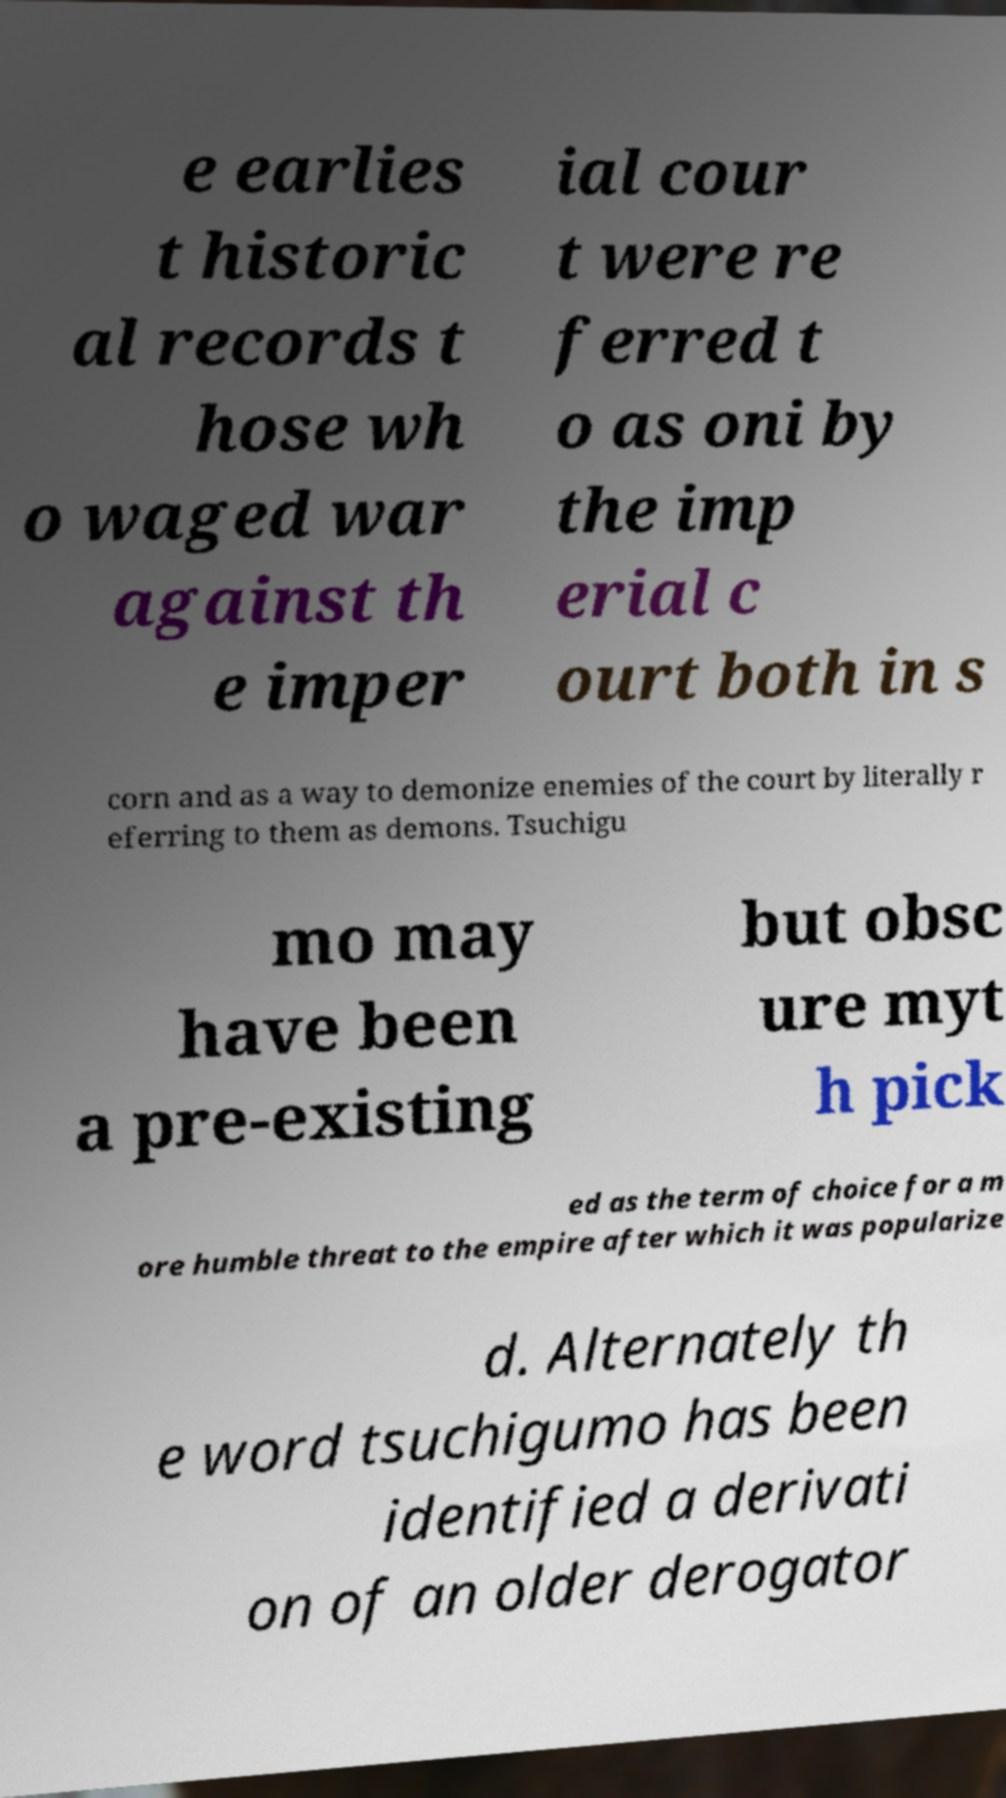Could you assist in decoding the text presented in this image and type it out clearly? e earlies t historic al records t hose wh o waged war against th e imper ial cour t were re ferred t o as oni by the imp erial c ourt both in s corn and as a way to demonize enemies of the court by literally r eferring to them as demons. Tsuchigu mo may have been a pre-existing but obsc ure myt h pick ed as the term of choice for a m ore humble threat to the empire after which it was popularize d. Alternately th e word tsuchigumo has been identified a derivati on of an older derogator 